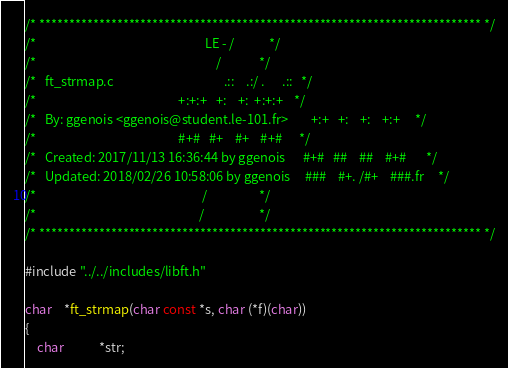<code> <loc_0><loc_0><loc_500><loc_500><_C_>/* ************************************************************************** */
/*                                                          LE - /            */
/*                                                              /             */
/*   ft_strmap.c                                      .::    .:/ .      .::   */
/*                                                 +:+:+   +:    +:  +:+:+    */
/*   By: ggenois <ggenois@student.le-101.fr>        +:+   +:    +:    +:+     */
/*                                                 #+#   #+    #+    #+#      */
/*   Created: 2017/11/13 16:36:44 by ggenois      #+#   ##    ##    #+#       */
/*   Updated: 2018/02/26 10:58:06 by ggenois     ###    #+. /#+    ###.fr     */
/*                                                         /                  */
/*                                                        /                   */
/* ************************************************************************** */

#include "../../includes/libft.h"

char	*ft_strmap(char const *s, char (*f)(char))
{
	char			*str;</code> 